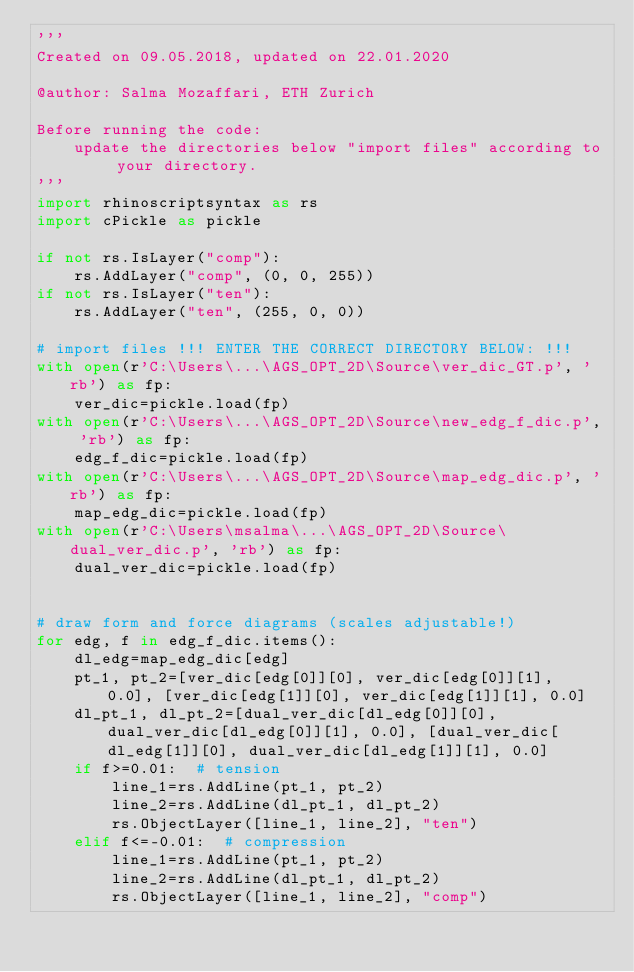<code> <loc_0><loc_0><loc_500><loc_500><_Python_>'''
Created on 09.05.2018, updated on 22.01.2020

@author: Salma Mozaffari, ETH Zurich

Before running the code:
    update the directories below "import files" according to your directory.
'''
import rhinoscriptsyntax as rs
import cPickle as pickle

if not rs.IsLayer("comp"):
    rs.AddLayer("comp", (0, 0, 255))
if not rs.IsLayer("ten"):
    rs.AddLayer("ten", (255, 0, 0))

# import files !!! ENTER THE CORRECT DIRECTORY BELOW: !!!
with open(r'C:\Users\...\AGS_OPT_2D\Source\ver_dic_GT.p', 'rb') as fp:
    ver_dic=pickle.load(fp)
with open(r'C:\Users\...\AGS_OPT_2D\Source\new_edg_f_dic.p', 'rb') as fp:
    edg_f_dic=pickle.load(fp)
with open(r'C:\Users\...\AGS_OPT_2D\Source\map_edg_dic.p', 'rb') as fp:
    map_edg_dic=pickle.load(fp)
with open(r'C:\Users\msalma\...\AGS_OPT_2D\Source\dual_ver_dic.p', 'rb') as fp:
    dual_ver_dic=pickle.load(fp)


# draw form and force diagrams (scales adjustable!)
for edg, f in edg_f_dic.items():
    dl_edg=map_edg_dic[edg]
    pt_1, pt_2=[ver_dic[edg[0]][0], ver_dic[edg[0]][1], 0.0], [ver_dic[edg[1]][0], ver_dic[edg[1]][1], 0.0]
    dl_pt_1, dl_pt_2=[dual_ver_dic[dl_edg[0]][0], dual_ver_dic[dl_edg[0]][1], 0.0], [dual_ver_dic[dl_edg[1]][0], dual_ver_dic[dl_edg[1]][1], 0.0]
    if f>=0.01:  # tension
        line_1=rs.AddLine(pt_1, pt_2)
        line_2=rs.AddLine(dl_pt_1, dl_pt_2)
        rs.ObjectLayer([line_1, line_2], "ten")
    elif f<=-0.01:  # compression
        line_1=rs.AddLine(pt_1, pt_2)
        line_2=rs.AddLine(dl_pt_1, dl_pt_2)
        rs.ObjectLayer([line_1, line_2], "comp")
</code> 